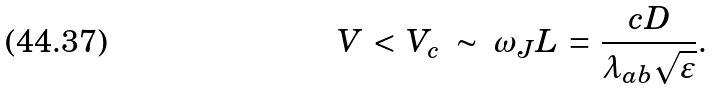<formula> <loc_0><loc_0><loc_500><loc_500>V \, < \, V _ { c } \ \sim \ \omega _ { J } L \, = \, \frac { c D } { \lambda _ { a b } \sqrt { \varepsilon } } .</formula> 